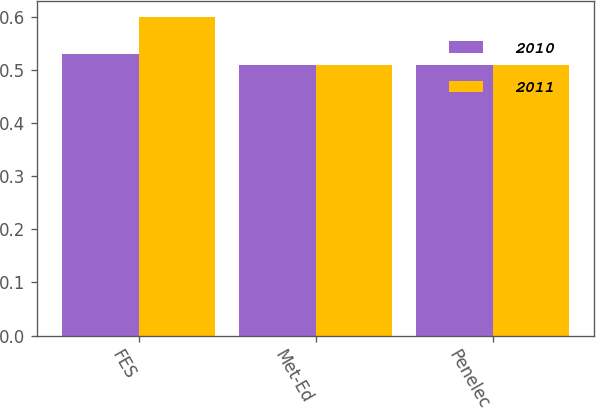Convert chart. <chart><loc_0><loc_0><loc_500><loc_500><stacked_bar_chart><ecel><fcel>FES<fcel>Met-Ed<fcel>Penelec<nl><fcel>2010<fcel>0.53<fcel>0.51<fcel>0.51<nl><fcel>2011<fcel>0.6<fcel>0.51<fcel>0.51<nl></chart> 